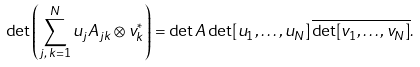<formula> <loc_0><loc_0><loc_500><loc_500>\det \left ( \sum _ { j , \, k = 1 } ^ { N } u _ { j } A _ { j k } \otimes v _ { k } ^ { \ast } \right ) = \det A \det [ u _ { 1 } , \dots , u _ { N } ] \, \overline { \det [ v _ { 1 } , \dots , v _ { N } ] } .</formula> 